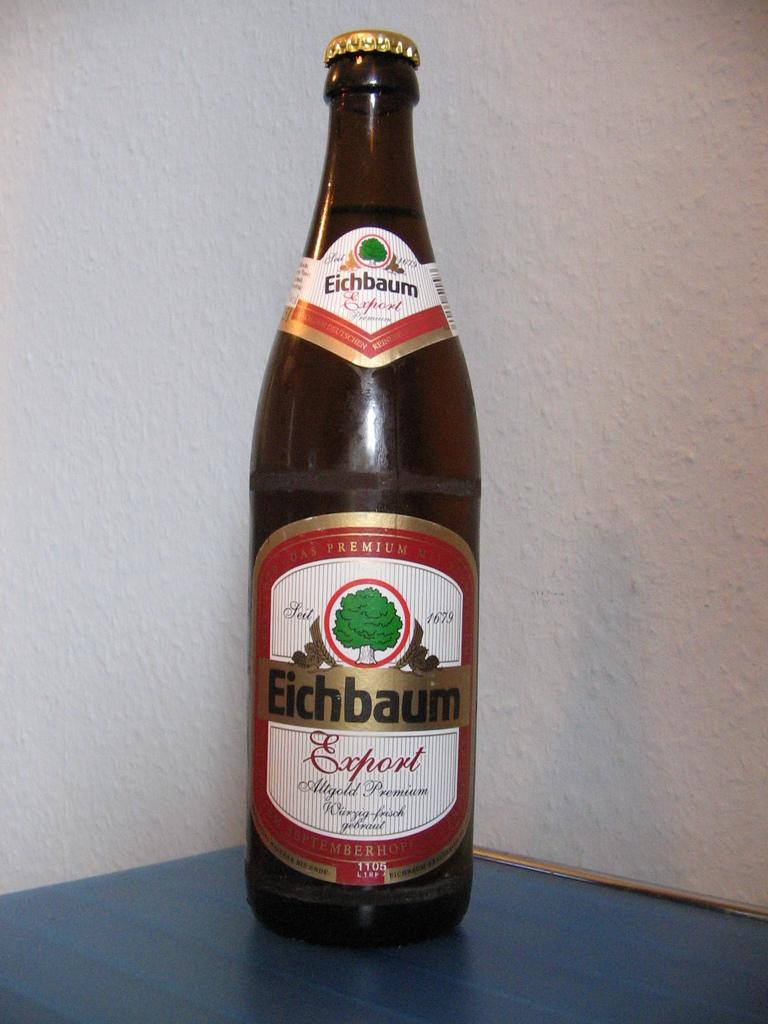What is the main object in the image? There is a bottle with a label in the image. Where is the bottle placed? The bottle is placed on a blue table. What can be seen in the background of the image? There is a white wall in the background of the image. How many babies are sitting in the pail in the image? There is no pail or babies present in the image. 